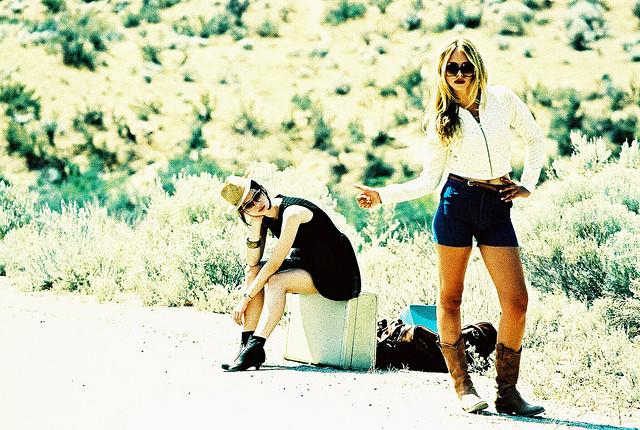What are the women doing on the road? hitchhiking 